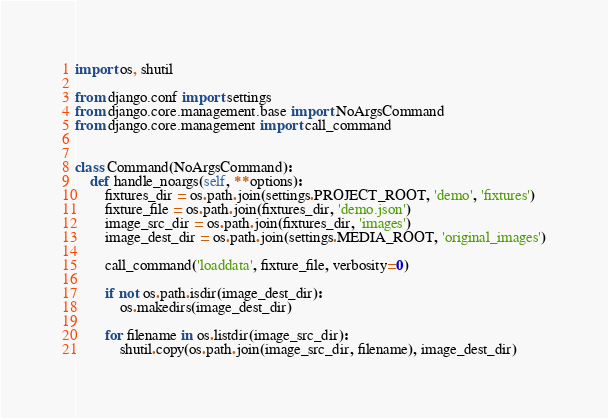Convert code to text. <code><loc_0><loc_0><loc_500><loc_500><_Python_>import os, shutil

from django.conf import settings
from django.core.management.base import NoArgsCommand
from django.core.management import call_command


class Command(NoArgsCommand):
    def handle_noargs(self, **options):
        fixtures_dir = os.path.join(settings.PROJECT_ROOT, 'demo', 'fixtures')
        fixture_file = os.path.join(fixtures_dir, 'demo.json')
        image_src_dir = os.path.join(fixtures_dir, 'images')
        image_dest_dir = os.path.join(settings.MEDIA_ROOT, 'original_images')

        call_command('loaddata', fixture_file, verbosity=0)

        if not os.path.isdir(image_dest_dir):
            os.makedirs(image_dest_dir)

        for filename in os.listdir(image_src_dir):
            shutil.copy(os.path.join(image_src_dir, filename), image_dest_dir)
</code> 